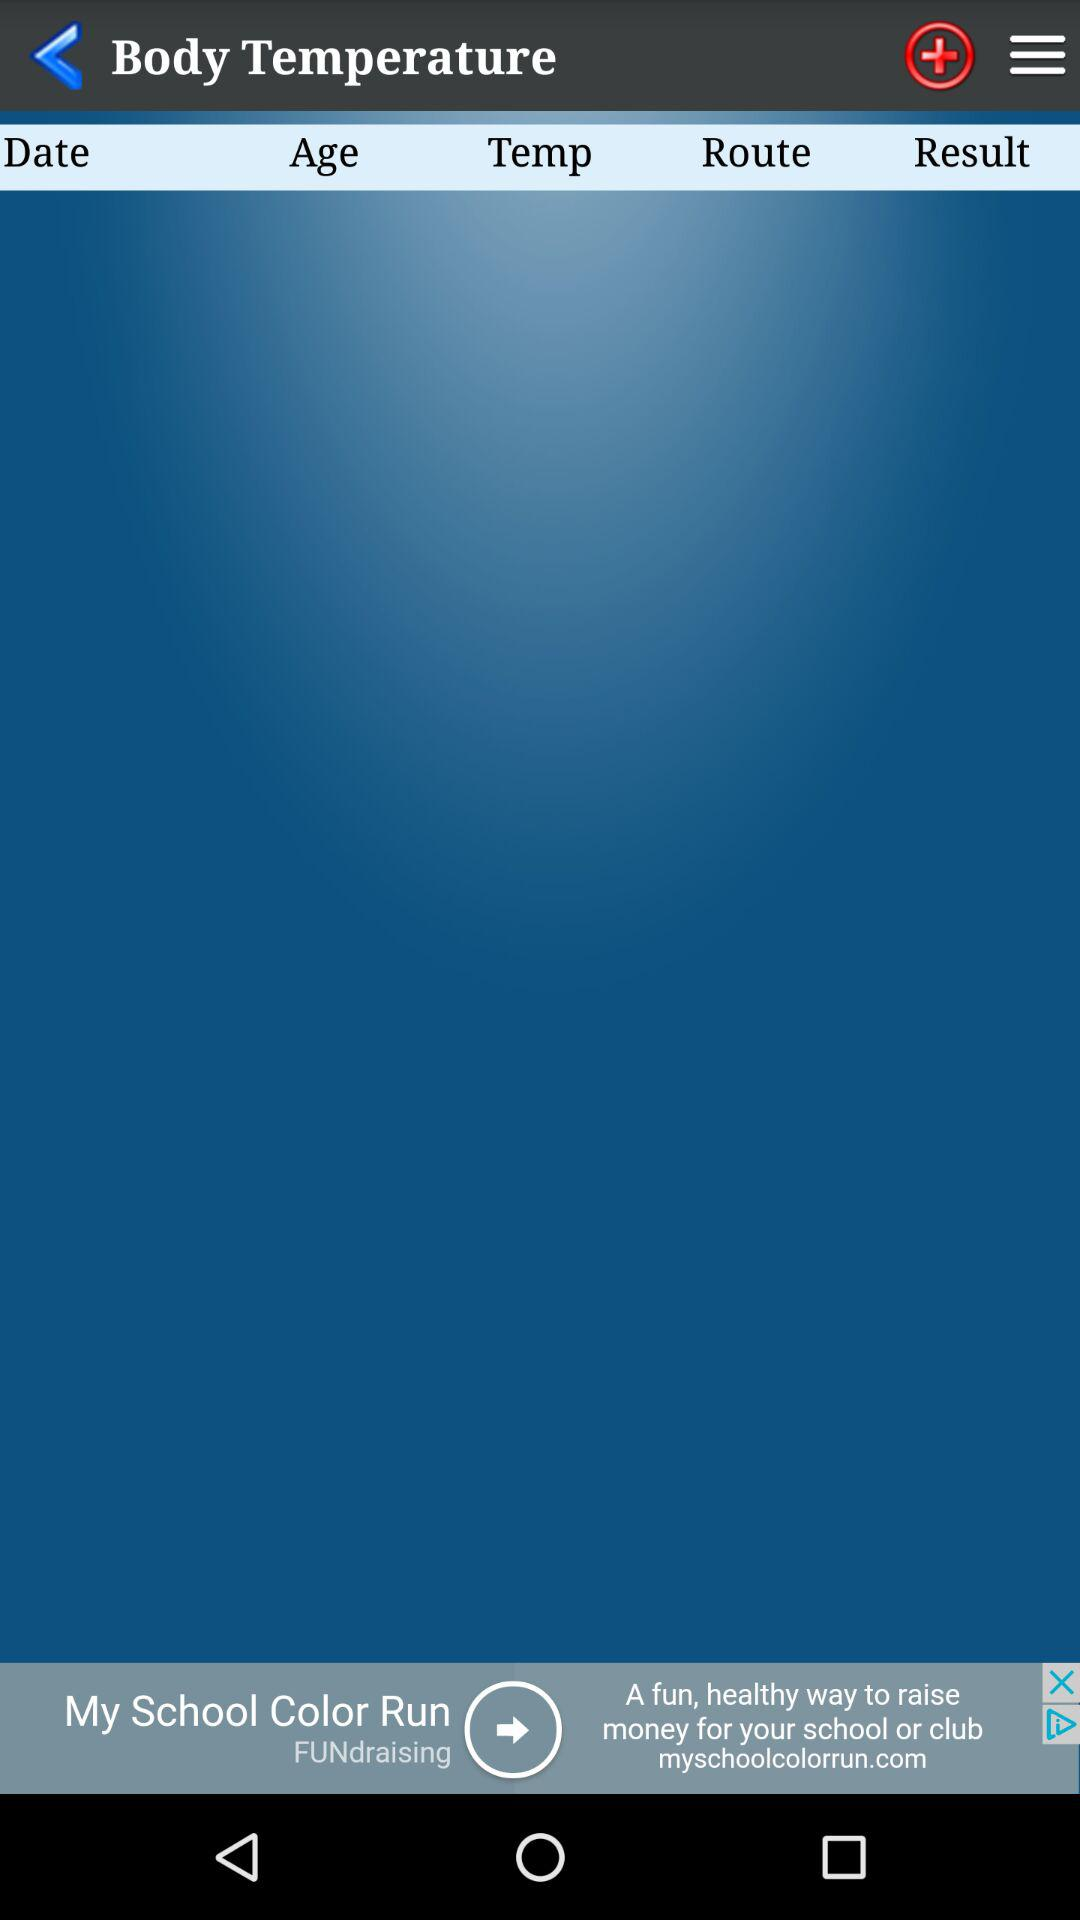What is the application name? The application name is "Body Temperature". 